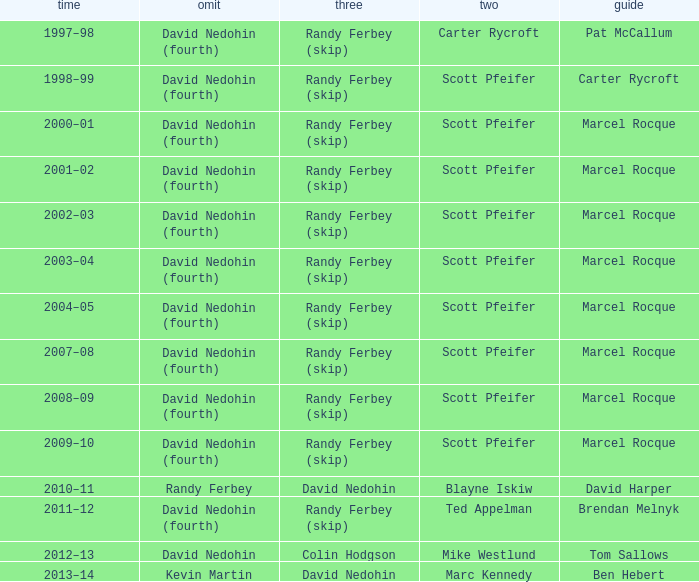Which Second has a Lead of ben hebert? Marc Kennedy. 